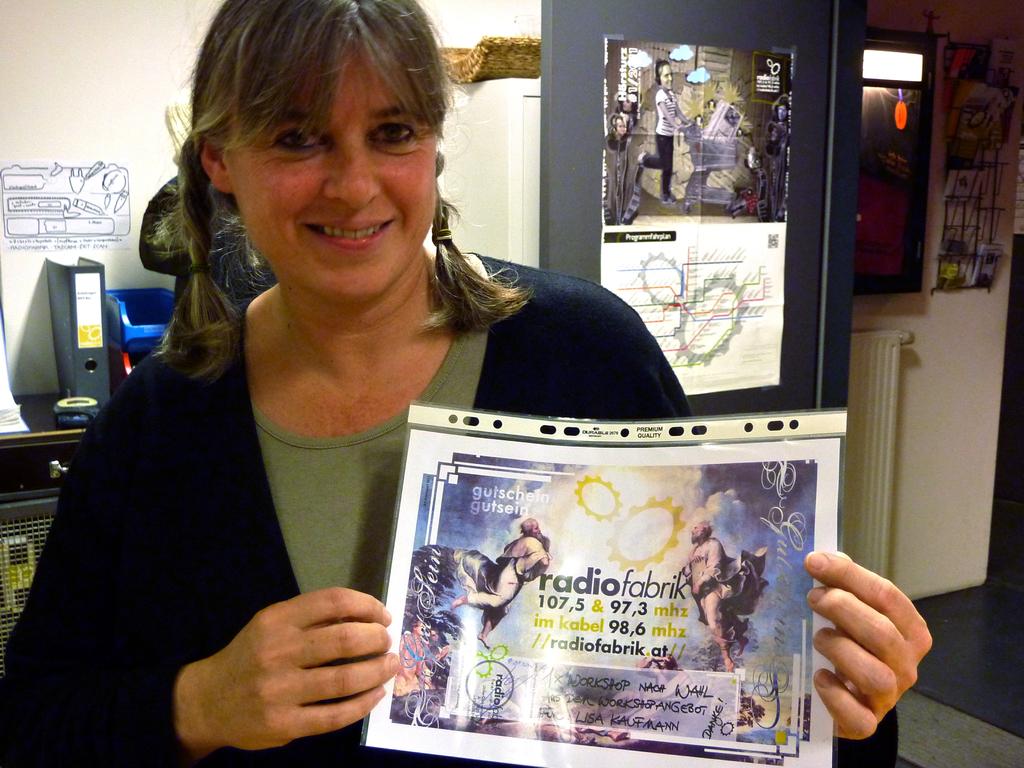What is the frequency  of the radio station the woman is displaying?
Offer a terse response. 107.5. 